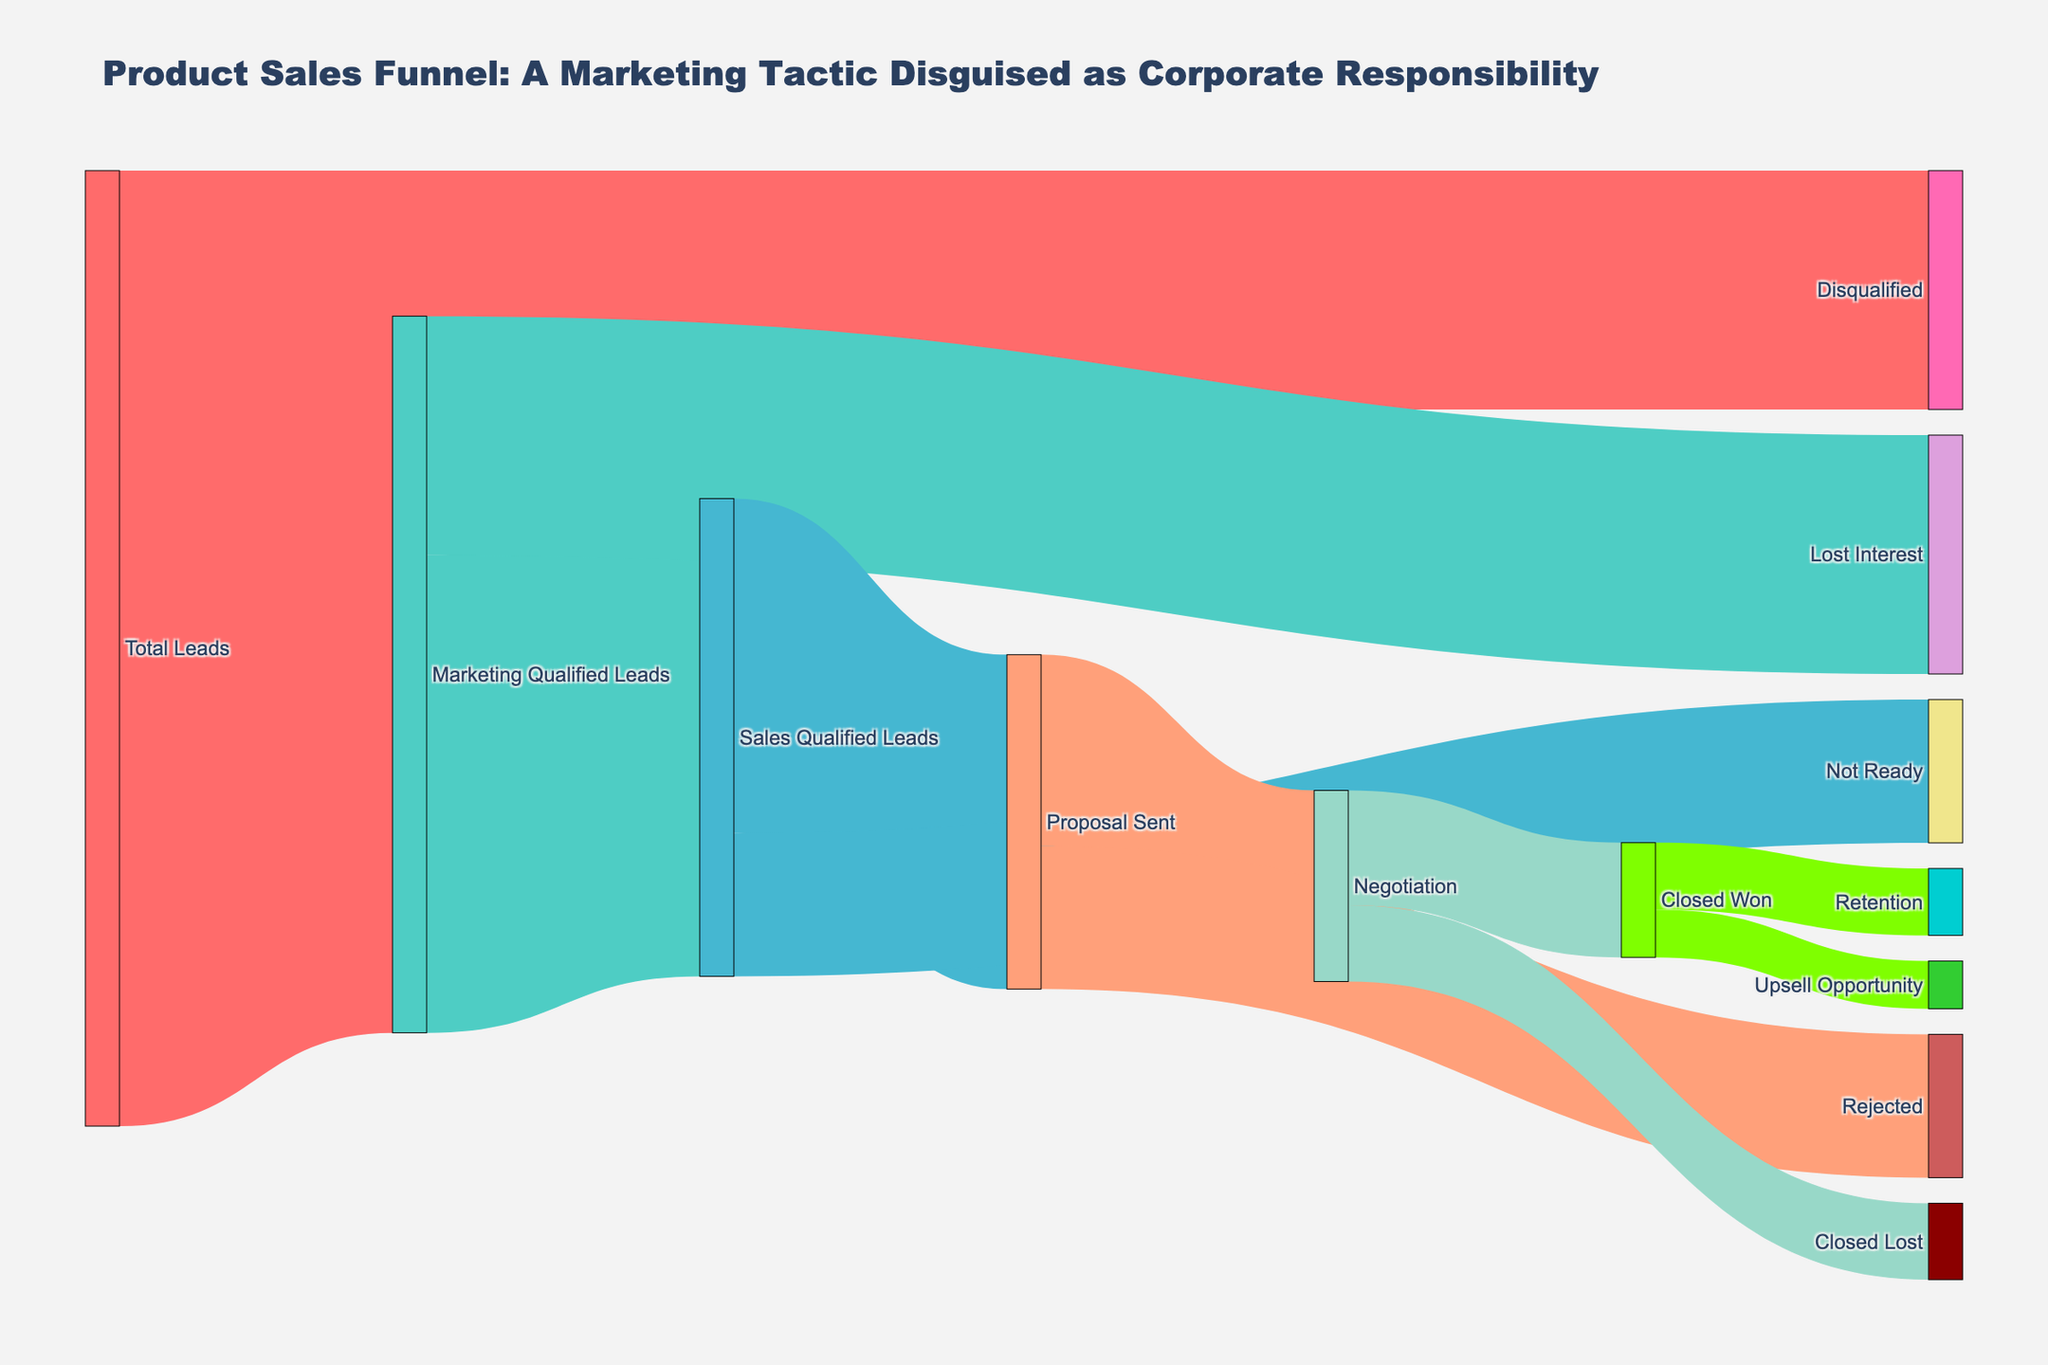What is the total number of leads that got disqualified? The Sankey diagram shows that "Total Leads" splits into "Marketing Qualified Leads" and "Disqualified". The value going towards "Disqualified" is provided directly.
Answer: 2500 How many leads progressed from "Sales Qualified Leads" to "Proposal Sent"? The diagram indicates the flow from "Sales Qualified Leads" to "Proposal Sent" with the value explicitly stated.
Answer: 3500 Which stage has the highest attrition from "Marketing Qualified Leads"? "Marketing Qualified Leads" splits into two stages: "Sales Qualified Leads" and "Lost Interest". Compare the values to determine which has the higher attrition value.
Answer: Lost Interest What is the total number of leads that reached the negotiation stage? To find the total in "Negotiation", sum the values from "Proposal Sent" to "Negotiation". This involves adding the values of the linked paths.
Answer: 2000 How many leads were ultimately converted into upsell opportunities? To determine the number of leads in "Upsell Opportunity", look at the flow from "Closed Won" to "Upsell Opportunity" and check the value associated with this link.
Answer: 500 Are there more leads in "Retention" or "Closed Lost"? Compare the values from "Closed Won" to "Retention" and from "Negotiation" to "Closed Lost".
Answer: Retention What is the cumulative attrition from "Proposal Sent" stage? Sum up the values leading away from "Proposal Sent" which include "Negotiation" and "Rejected" to find the total attrition at this stage.
Answer: 3500 Which final stage retains the most leads from the "Closed Won" category? Compare the values splitting from "Closed Won", specifically "Upsell Opportunity" and "Retention". The higher value indicates the stage with more retained leads.
Answer: Retention How many leads were lost before reaching the "Sales Qualified Leads" stage? Combine the values of leads lost from initial "Total Leads" and from "Marketing Qualified Leads" before arriving at "Sales Qualified Leads". This sums up the leads that were "Disqualified" and "Lost Interest".
Answer: 5000 Which stage between "Proposal Sent" and "Negotiation" had the most rejections? Compare and identify which stage had more leads rejected by looking at links "Proposal Sent" to "Rejected" and "Negotiation" to "Closed Lost".
Answer: Proposal Sent 